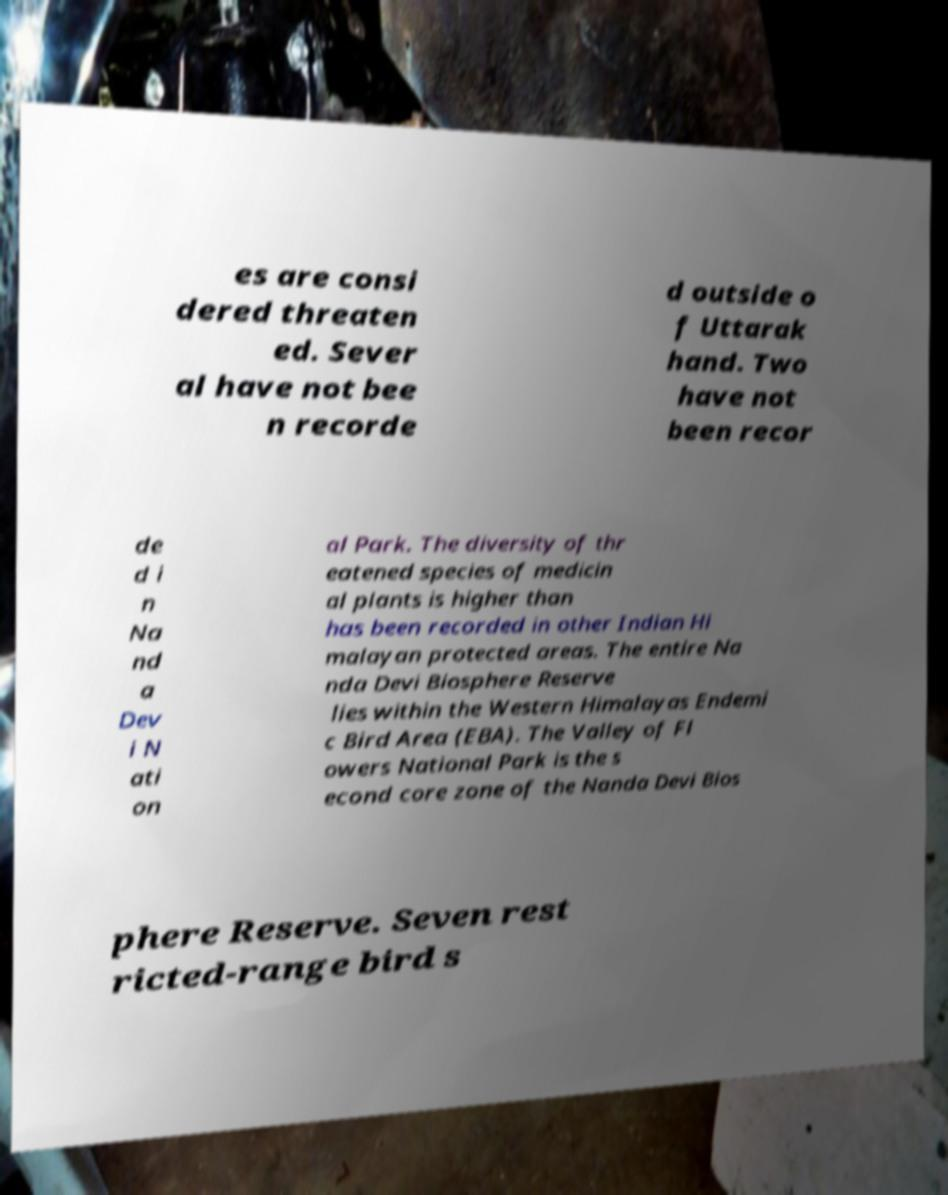Can you accurately transcribe the text from the provided image for me? es are consi dered threaten ed. Sever al have not bee n recorde d outside o f Uttarak hand. Two have not been recor de d i n Na nd a Dev i N ati on al Park. The diversity of thr eatened species of medicin al plants is higher than has been recorded in other Indian Hi malayan protected areas. The entire Na nda Devi Biosphere Reserve lies within the Western Himalayas Endemi c Bird Area (EBA). The Valley of Fl owers National Park is the s econd core zone of the Nanda Devi Bios phere Reserve. Seven rest ricted-range bird s 